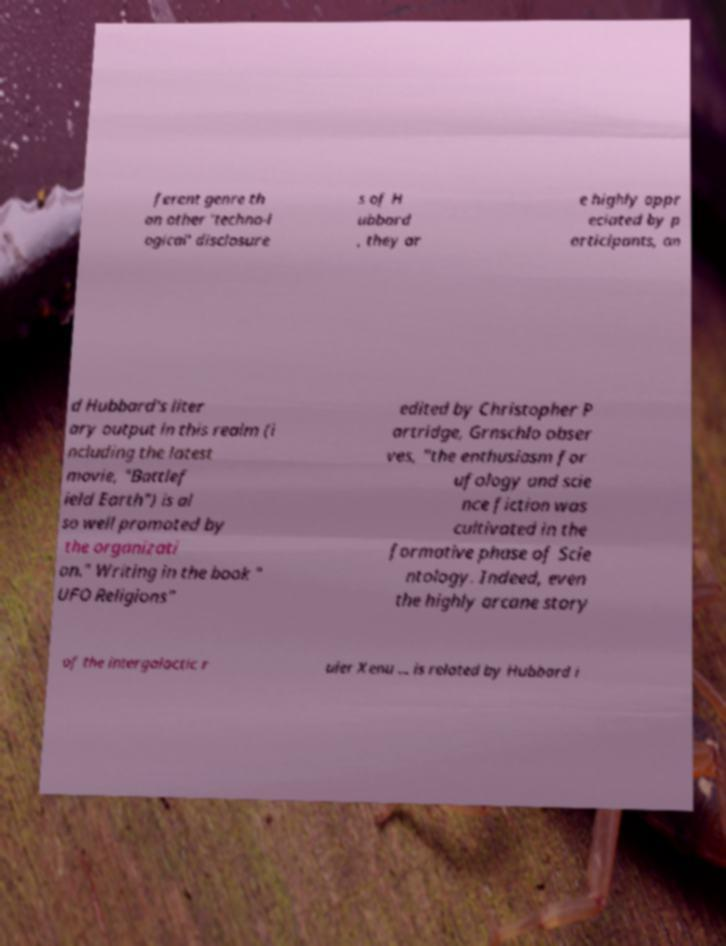Please identify and transcribe the text found in this image. ferent genre th an other 'techno-l ogical' disclosure s of H ubbard , they ar e highly appr eciated by p articipants, an d Hubbard's liter ary output in this realm (i ncluding the latest movie, "Battlef ield Earth") is al so well promoted by the organizati on." Writing in the book " UFO Religions" edited by Christopher P artridge, Grnschlo obser ves, "the enthusiasm for ufology and scie nce fiction was cultivated in the formative phase of Scie ntology. Indeed, even the highly arcane story of the intergalactic r uler Xenu ... is related by Hubbard i 